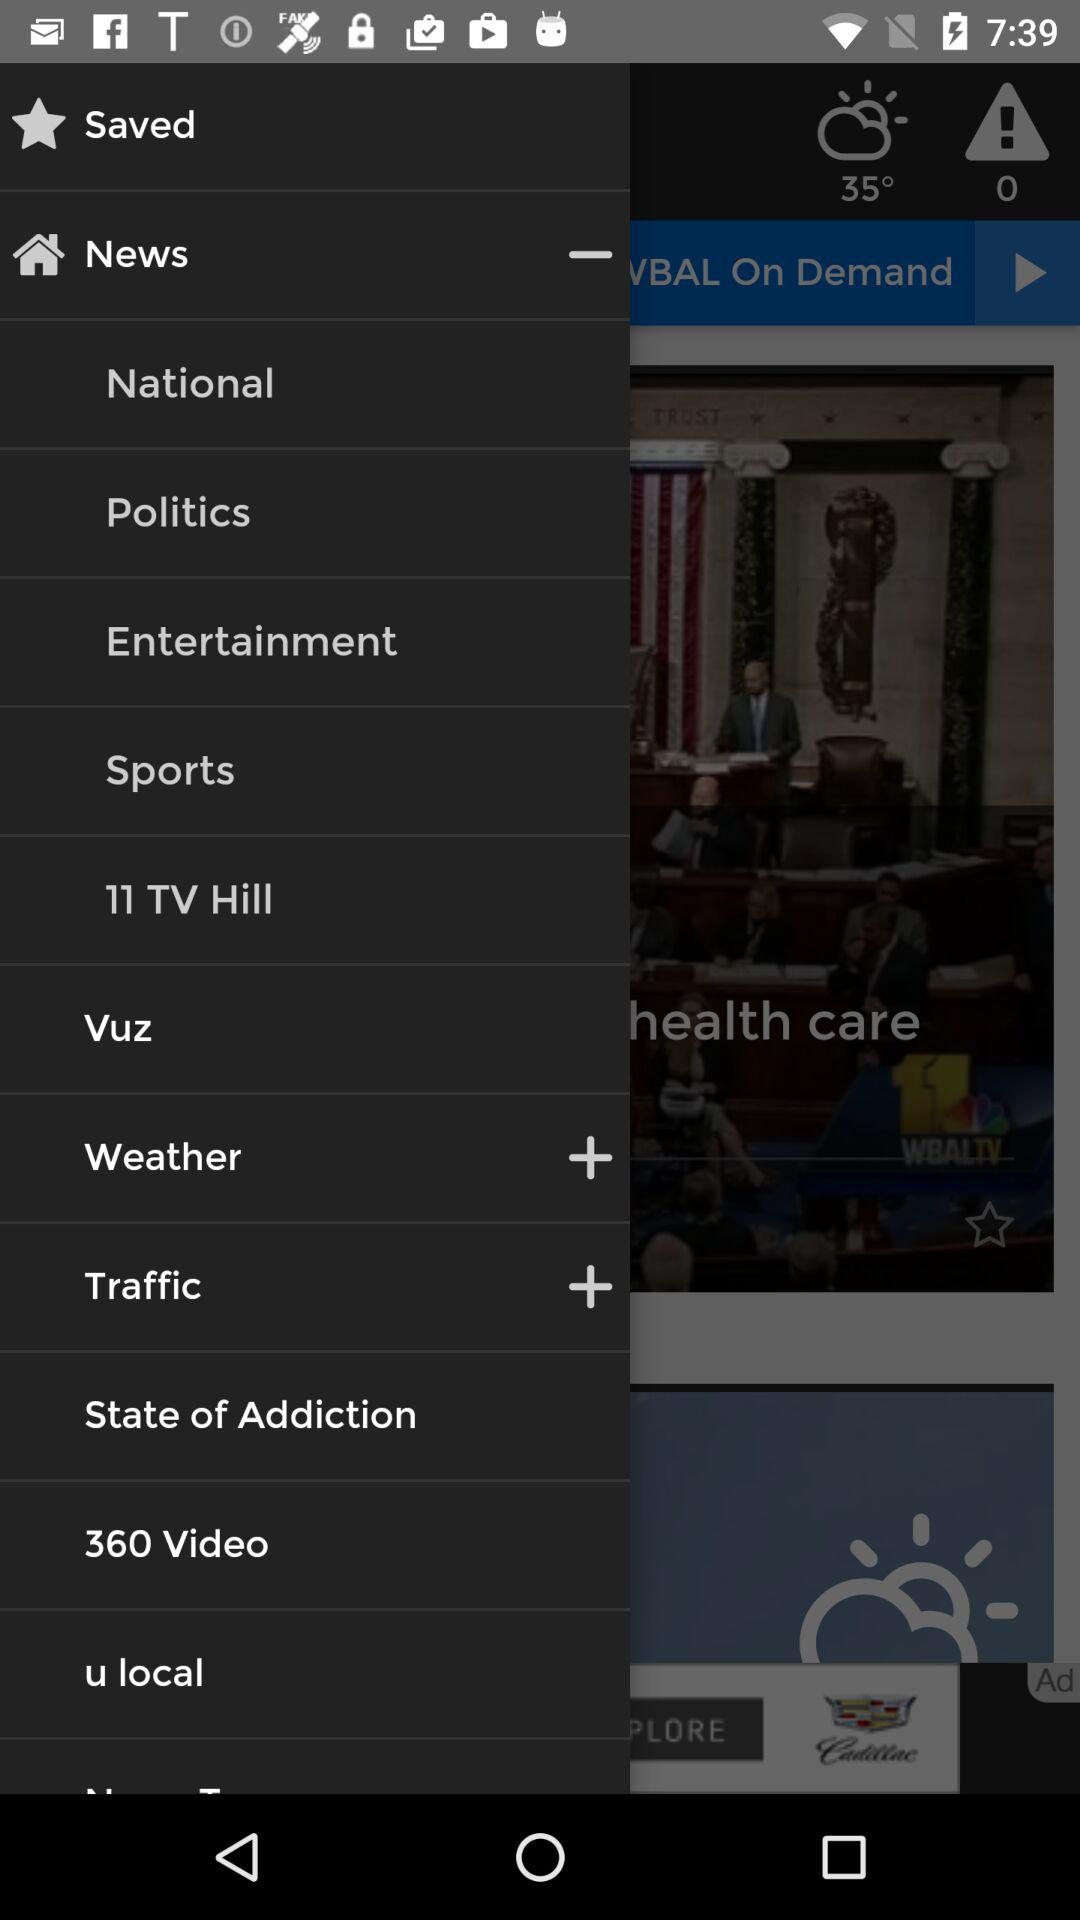What is the shown temperature? The temperature is 35°. 